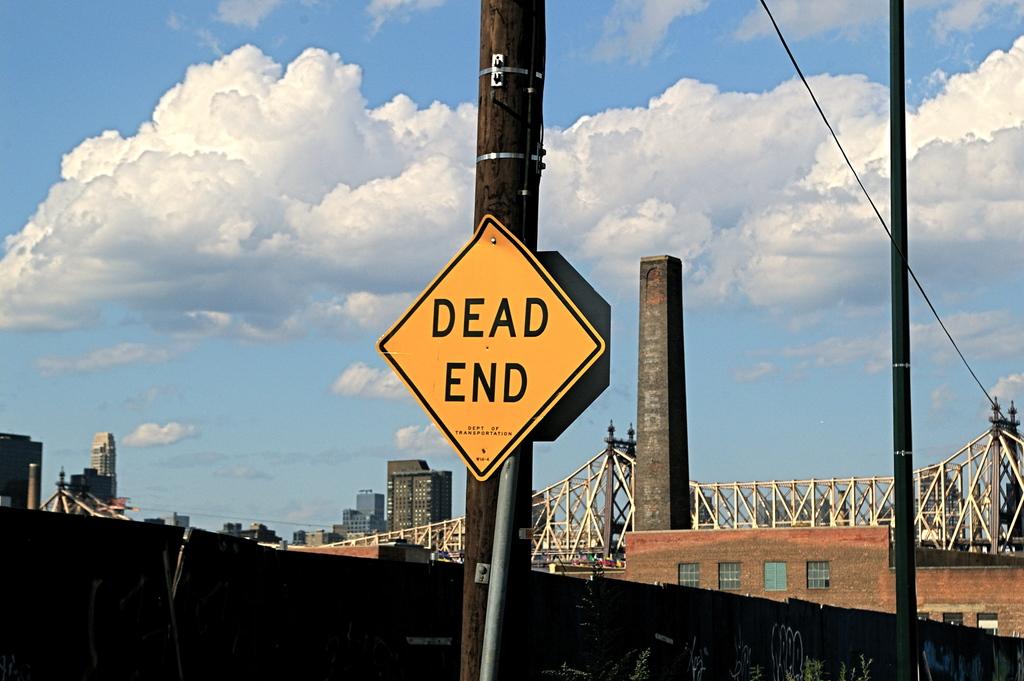What does the sign say?
Offer a very short reply. Dead end. What is the last letter of the bottom word on the sign?
Your response must be concise. D. 